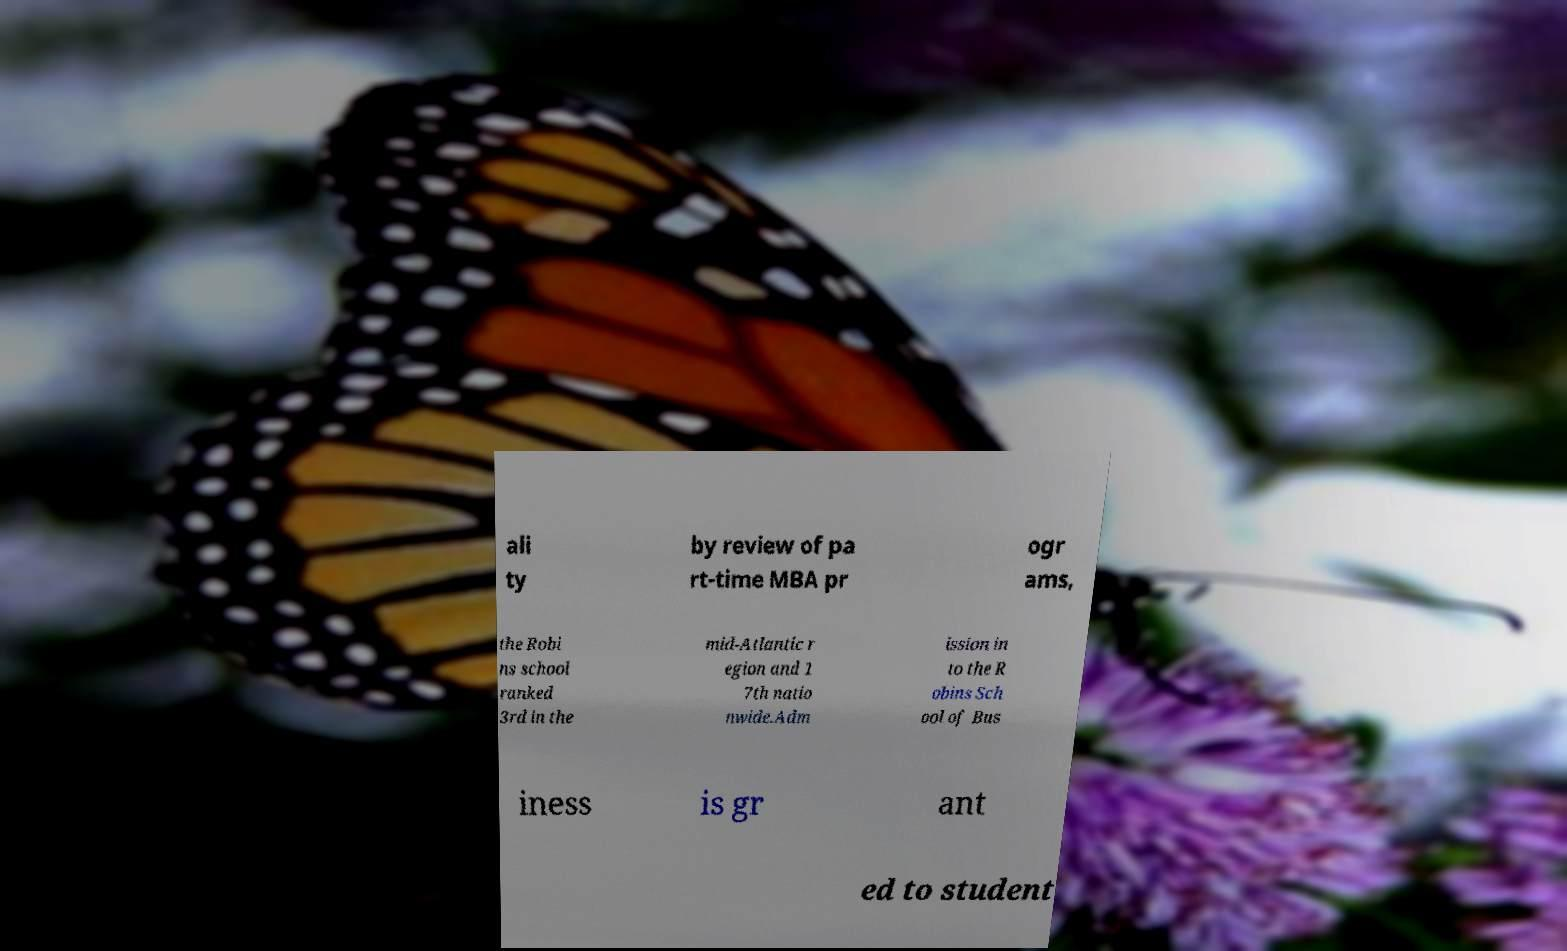Can you read and provide the text displayed in the image?This photo seems to have some interesting text. Can you extract and type it out for me? ali ty by review of pa rt-time MBA pr ogr ams, the Robi ns school ranked 3rd in the mid-Atlantic r egion and 1 7th natio nwide.Adm ission in to the R obins Sch ool of Bus iness is gr ant ed to student 